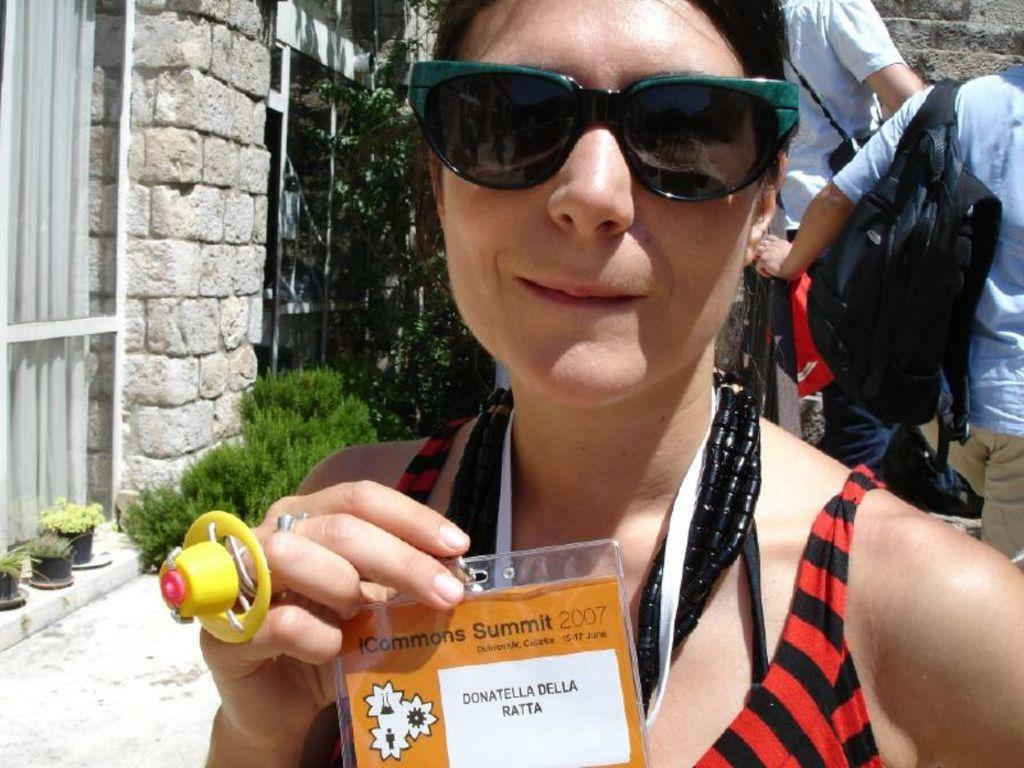Who is the main subject in the image? There is a lady in the center of the image. What is the lady holding in the image? The lady is holding a card. What accessory is the lady wearing in the image? The lady is wearing sunglasses. What can be seen in the background of the image? There are windows, greenery, and people in the background. What type of structure is visible in the background? There is a wall in the background. What type of grain is being discussed by the minister in the image? There is no minister or discussion about grain present in the image. What question is the lady asking the person in the background? There is no question being asked by the lady in the image. 